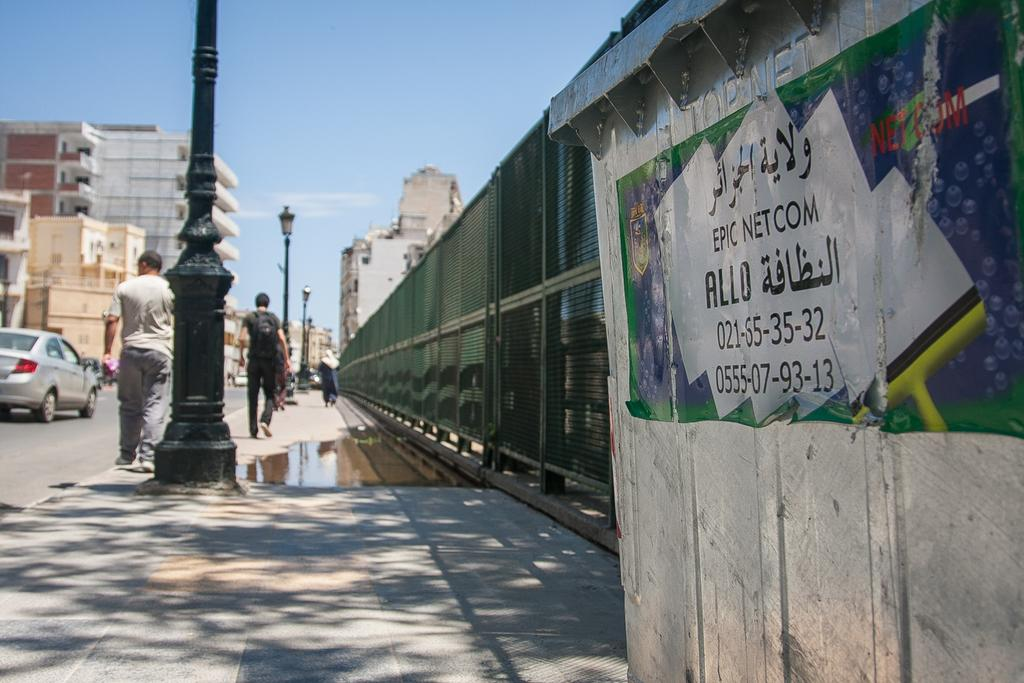Provide a one-sentence caption for the provided image. A view down a city street with people walking down it past a telecoms box whih has arabic writing and also the words Epic Netcom on it. 